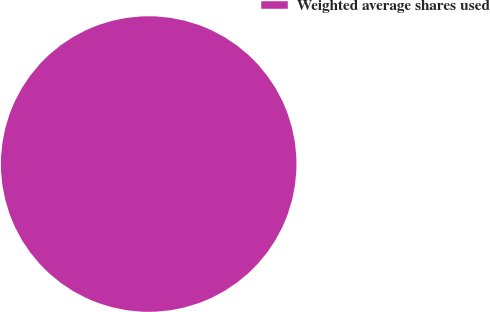Convert chart. <chart><loc_0><loc_0><loc_500><loc_500><pie_chart><fcel>Weighted average shares used<nl><fcel>100.0%<nl></chart> 